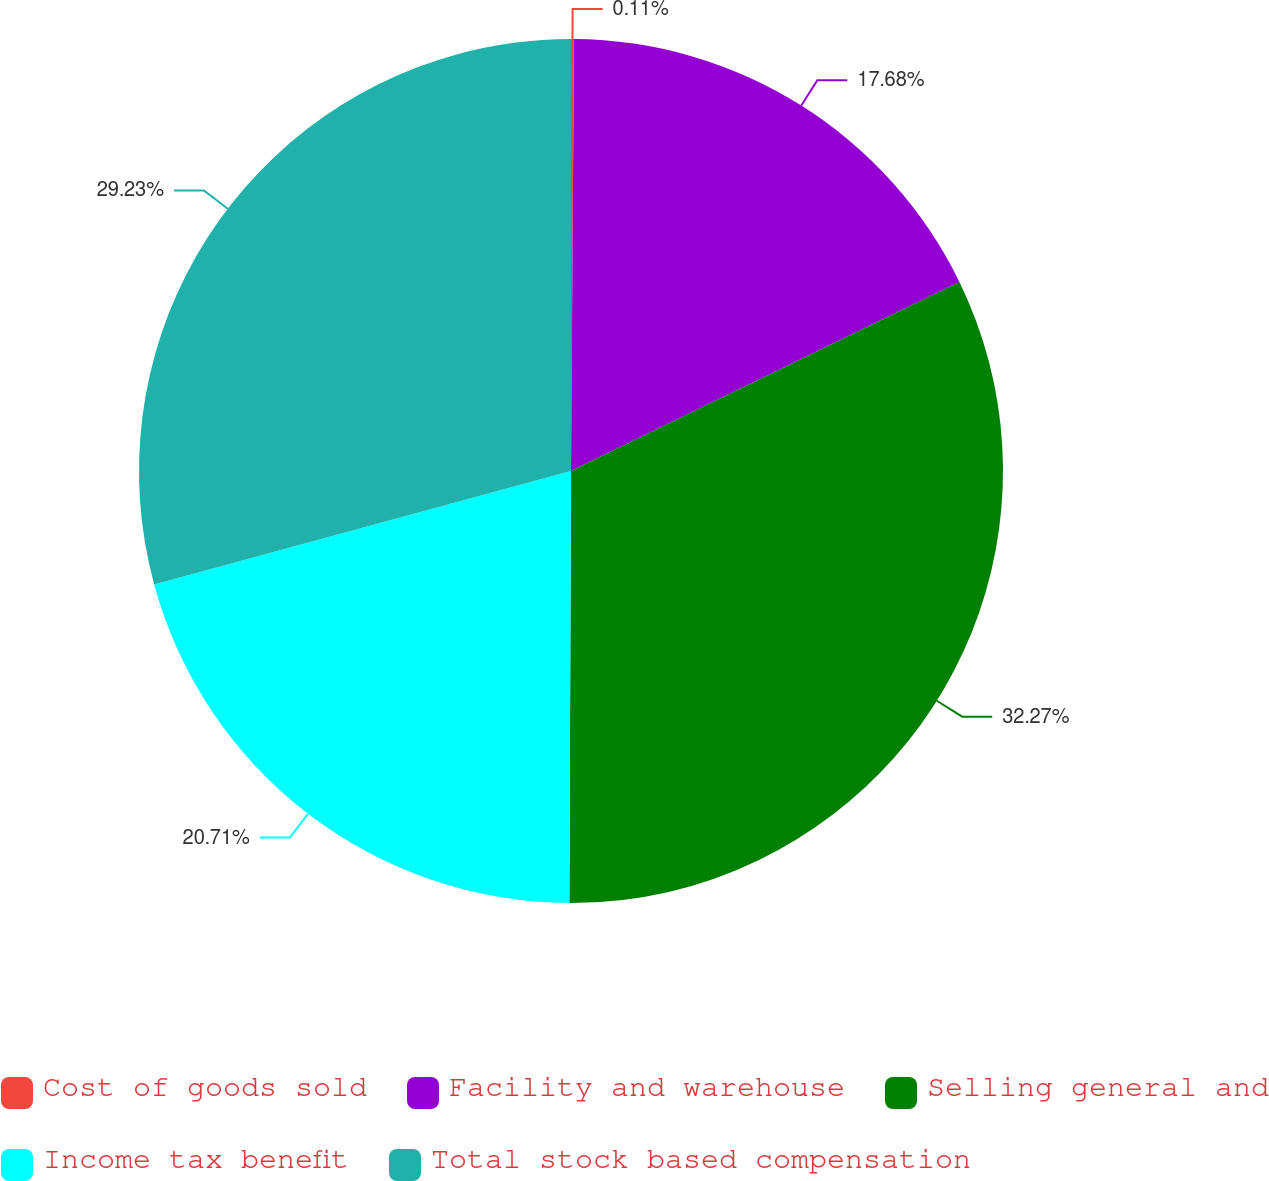<chart> <loc_0><loc_0><loc_500><loc_500><pie_chart><fcel>Cost of goods sold<fcel>Facility and warehouse<fcel>Selling general and<fcel>Income tax benefit<fcel>Total stock based compensation<nl><fcel>0.11%<fcel>17.68%<fcel>32.27%<fcel>20.71%<fcel>29.23%<nl></chart> 